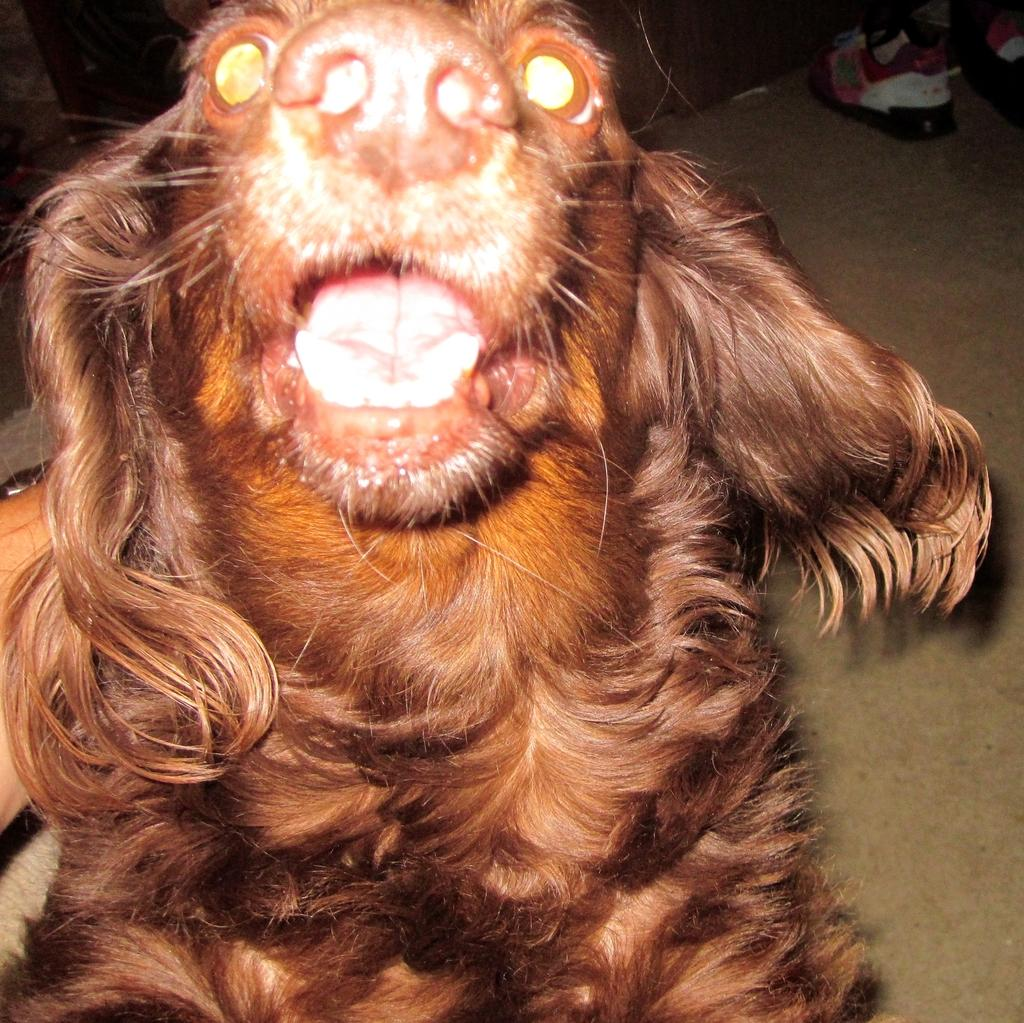What is the main subject in the front of the image? There is a dog in the front of the image. What else can be seen in the background of the image? There are shoes visible in the background of the image. How does the dog sleep in the image? The image does not show the dog sleeping; it is in the front of the image. 